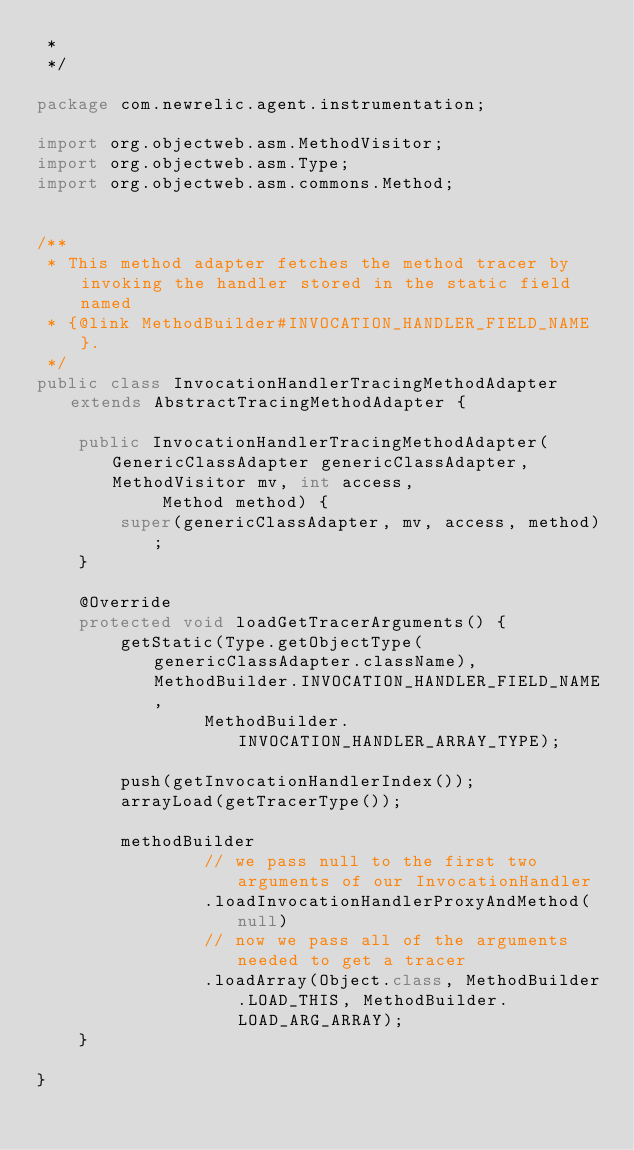<code> <loc_0><loc_0><loc_500><loc_500><_Java_> *
 */

package com.newrelic.agent.instrumentation;

import org.objectweb.asm.MethodVisitor;
import org.objectweb.asm.Type;
import org.objectweb.asm.commons.Method;


/**
 * This method adapter fetches the method tracer by invoking the handler stored in the static field named
 * {@link MethodBuilder#INVOCATION_HANDLER_FIELD_NAME}.
 */
public class InvocationHandlerTracingMethodAdapter extends AbstractTracingMethodAdapter {

    public InvocationHandlerTracingMethodAdapter(GenericClassAdapter genericClassAdapter, MethodVisitor mv, int access,
            Method method) {
        super(genericClassAdapter, mv, access, method);
    }

    @Override
    protected void loadGetTracerArguments() {
        getStatic(Type.getObjectType(genericClassAdapter.className), MethodBuilder.INVOCATION_HANDLER_FIELD_NAME,
                MethodBuilder.INVOCATION_HANDLER_ARRAY_TYPE);

        push(getInvocationHandlerIndex());
        arrayLoad(getTracerType());

        methodBuilder
                // we pass null to the first two arguments of our InvocationHandler
                .loadInvocationHandlerProxyAndMethod(null)
                // now we pass all of the arguments needed to get a tracer
                .loadArray(Object.class, MethodBuilder.LOAD_THIS, MethodBuilder.LOAD_ARG_ARRAY);
    }

}
</code> 